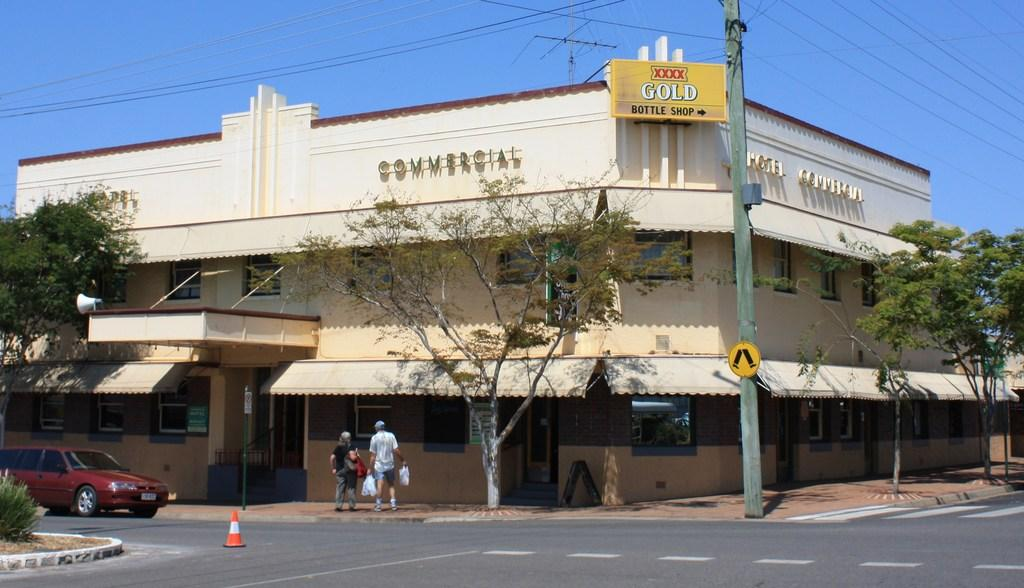What is on the road in the image? There is a car on the road in the image. What object can be seen near the car? There is a traffic cone in the image. What type of vegetation is present in the image? There is a plant and trees in the image. What structure is visible in the image? There is a building in the image. What other objects can be seen in the image? There is a pole, boards, and two persons in the image. What can be seen in the background of the image? The sky is visible in the background of the image. Can you tell me how many squirrels are sitting on the mailbox in the image? There are no squirrels or mailboxes present in the image. What type of business is being conducted in the image? The image does not depict any specific business activity; it shows a car, traffic cone, plant, pole, trees, building, boards, and two persons. 